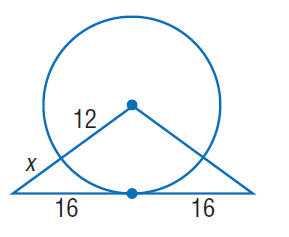Question: Find x. Assume that segments that appear to be tangent are tangent.
Choices:
A. 8
B. 12
C. 16
D. 32
Answer with the letter. Answer: A 